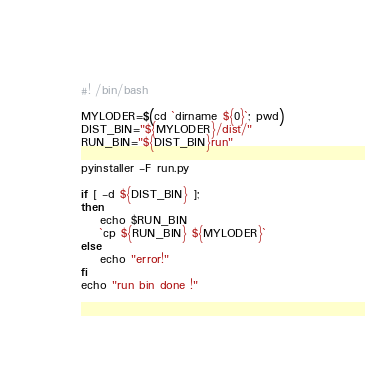<code> <loc_0><loc_0><loc_500><loc_500><_Bash_>#! /bin/bash

MYLODER=$(cd `dirname ${0}`; pwd)
DIST_BIN="${MYLODER}/dist/"
RUN_BIN="${DIST_BIN}run"

pyinstaller -F run.py

if [ -d ${DIST_BIN} ];
then
    echo $RUN_BIN
    `cp ${RUN_BIN} ${MYLODER}`
else
    echo "error!"
fi
echo "run bin done !"


</code> 